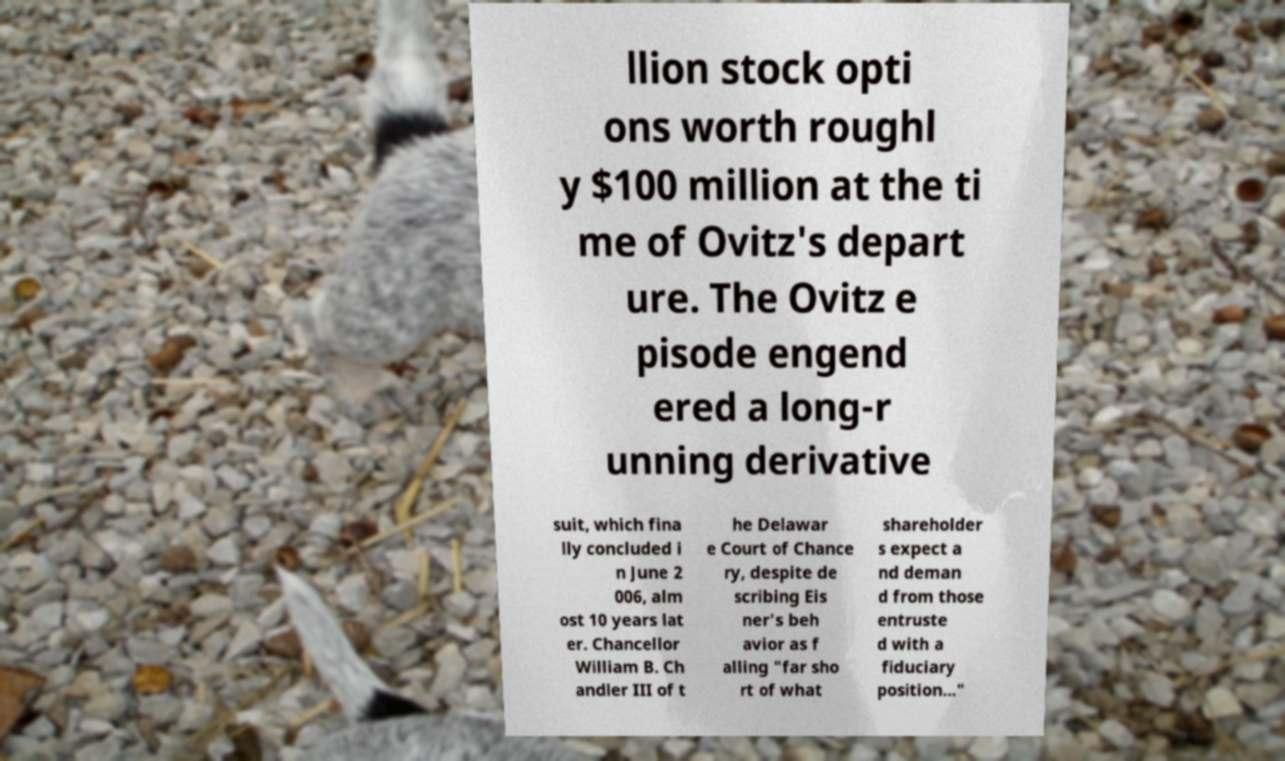For documentation purposes, I need the text within this image transcribed. Could you provide that? llion stock opti ons worth roughl y $100 million at the ti me of Ovitz's depart ure. The Ovitz e pisode engend ered a long-r unning derivative suit, which fina lly concluded i n June 2 006, alm ost 10 years lat er. Chancellor William B. Ch andler III of t he Delawar e Court of Chance ry, despite de scribing Eis ner's beh avior as f alling "far sho rt of what shareholder s expect a nd deman d from those entruste d with a fiduciary position..." 